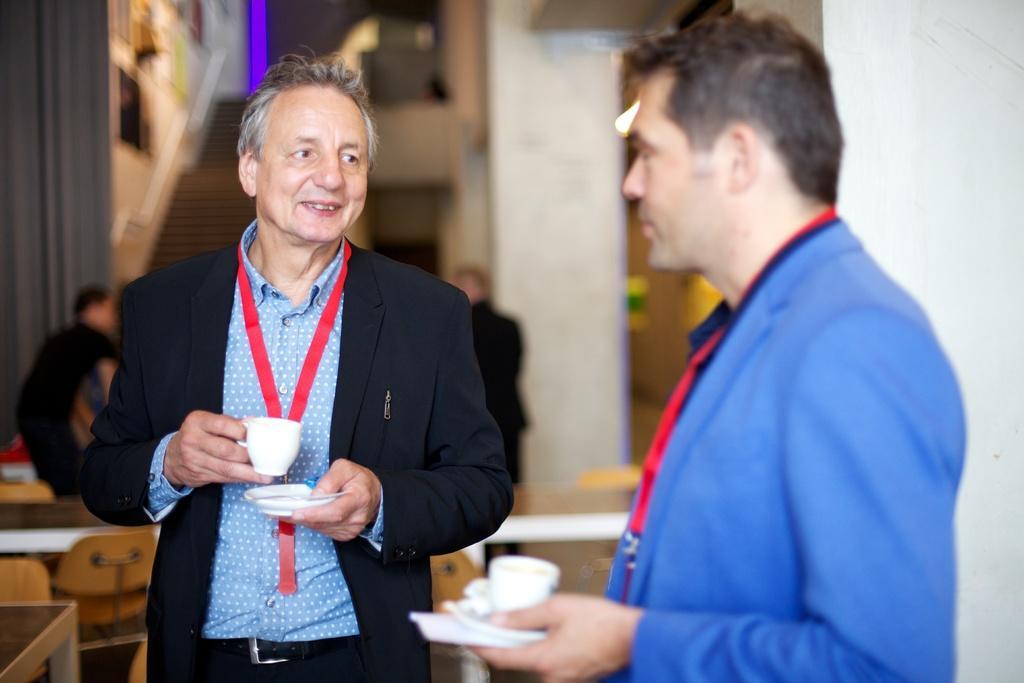How would you summarize this image in a sentence or two? In this image we can see two men are standing. They are holding cups, saucers and tissue in their hands. We can see tags around their necks. In the background, we can see people, wall, stairs and frames on the wall. On the left side of the image, we can see tables and chairs. 